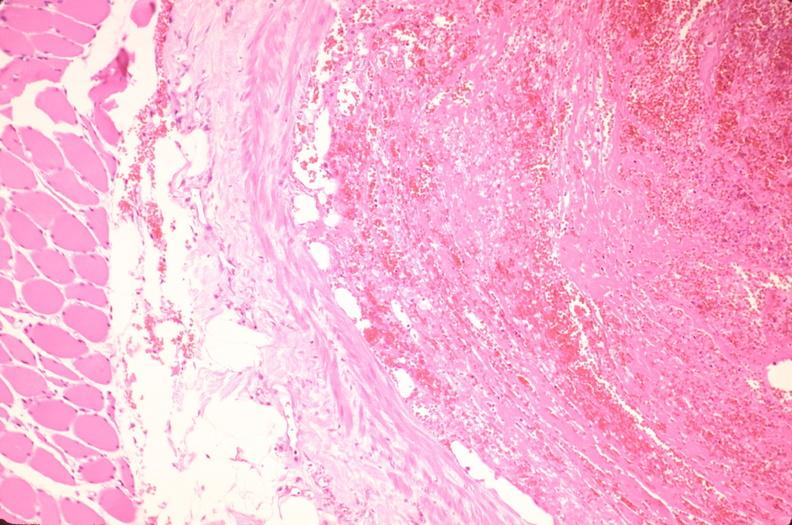what is present?
Answer the question using a single word or phrase. Cardiovascular 